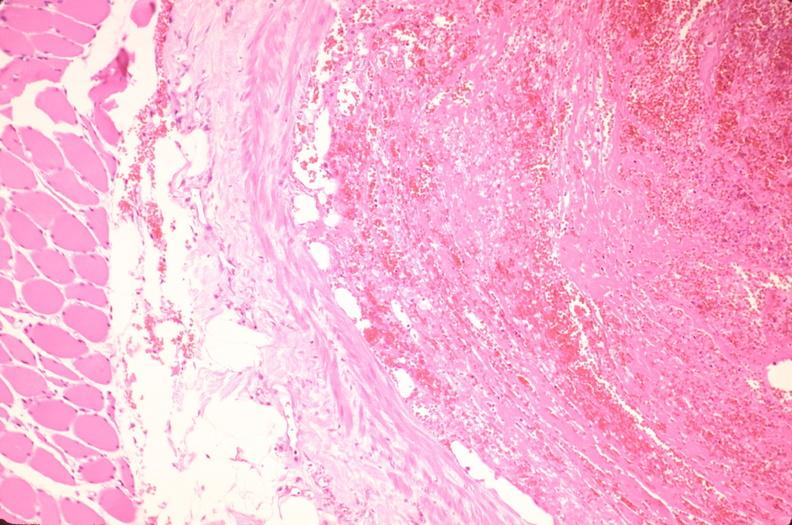what is present?
Answer the question using a single word or phrase. Cardiovascular 